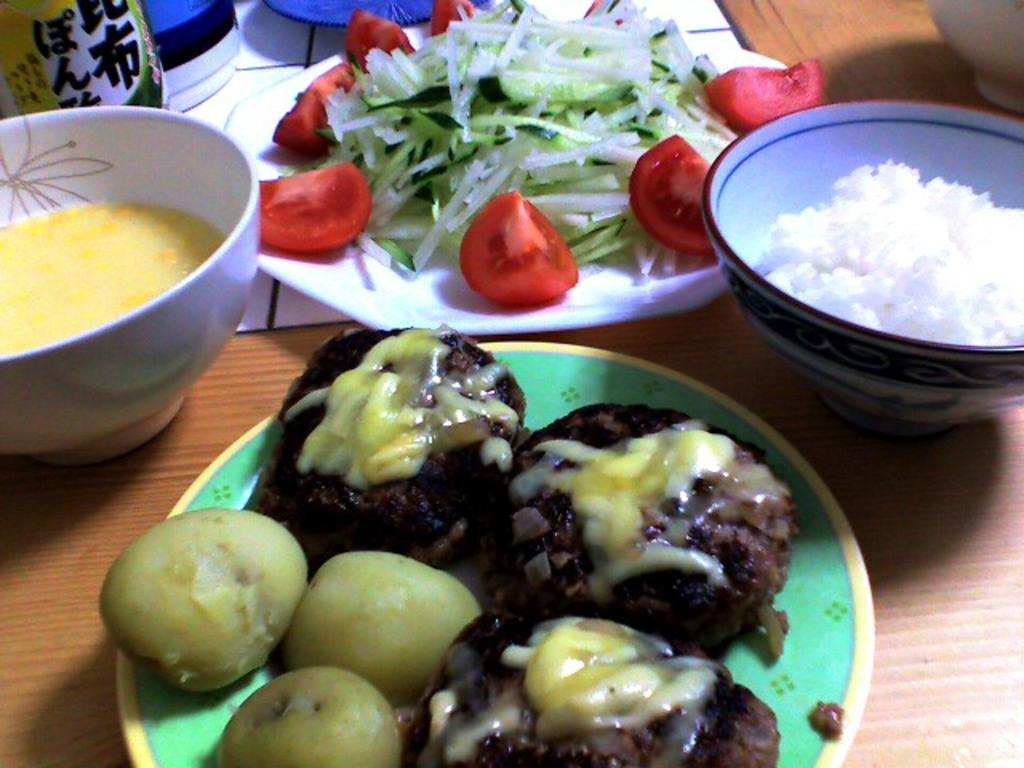What type of food can be seen in the image? The image contains food, but the specific type cannot be determined from the facts provided. What type of dishware is present in the image? There are plates and bowls in the image. On what surface are the plates, bowls, and food placed? The objects are on a wooden platform. What is the smell of the food in the image? The smell of the food cannot be determined from the image, as smell is not a visual characteristic. 